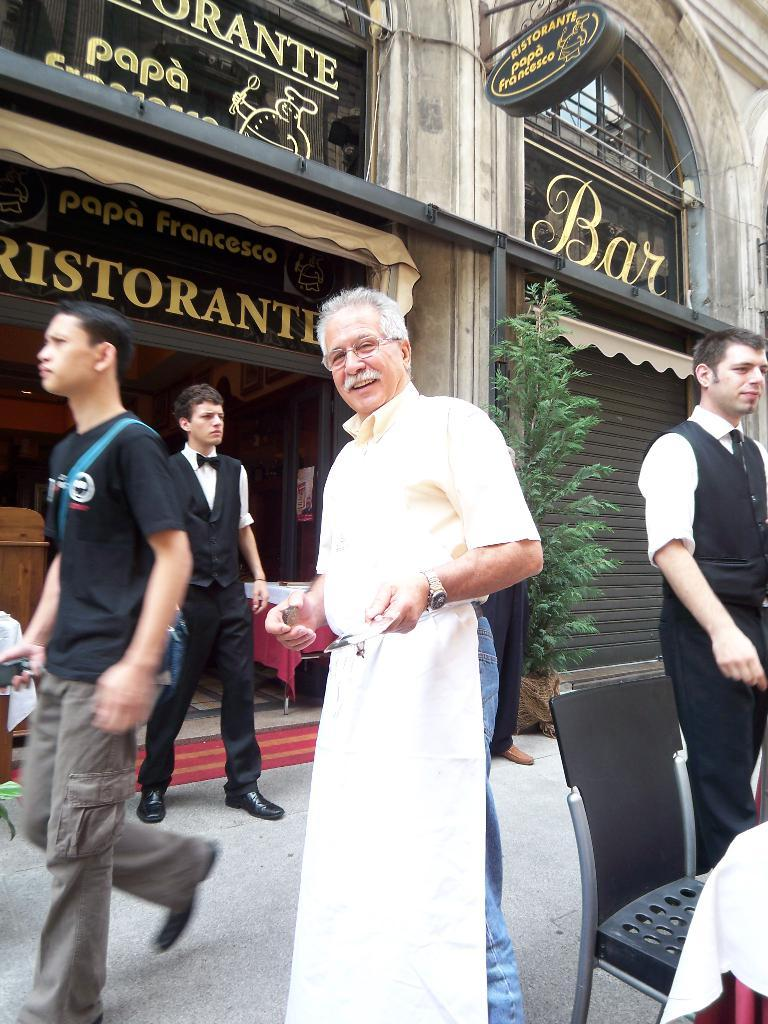What is happening on the road in the image? There are persons on the road in the image. Can you describe the facial expression of one of the persons? One person is smiling. What accessory does the person have? The person has spectacles. What type of furniture is present in the image? There is a chair in the image. What can be seen in the background of the image? There is a building and a board in the background. What type of vegetation is present in the image? There is a plant in the image. What attempt is the person making to reach the star in the image? There is no star present in the image, and therefore no attempt can be observed. What letter is the person holding in the image? There is no letter present in the image. 